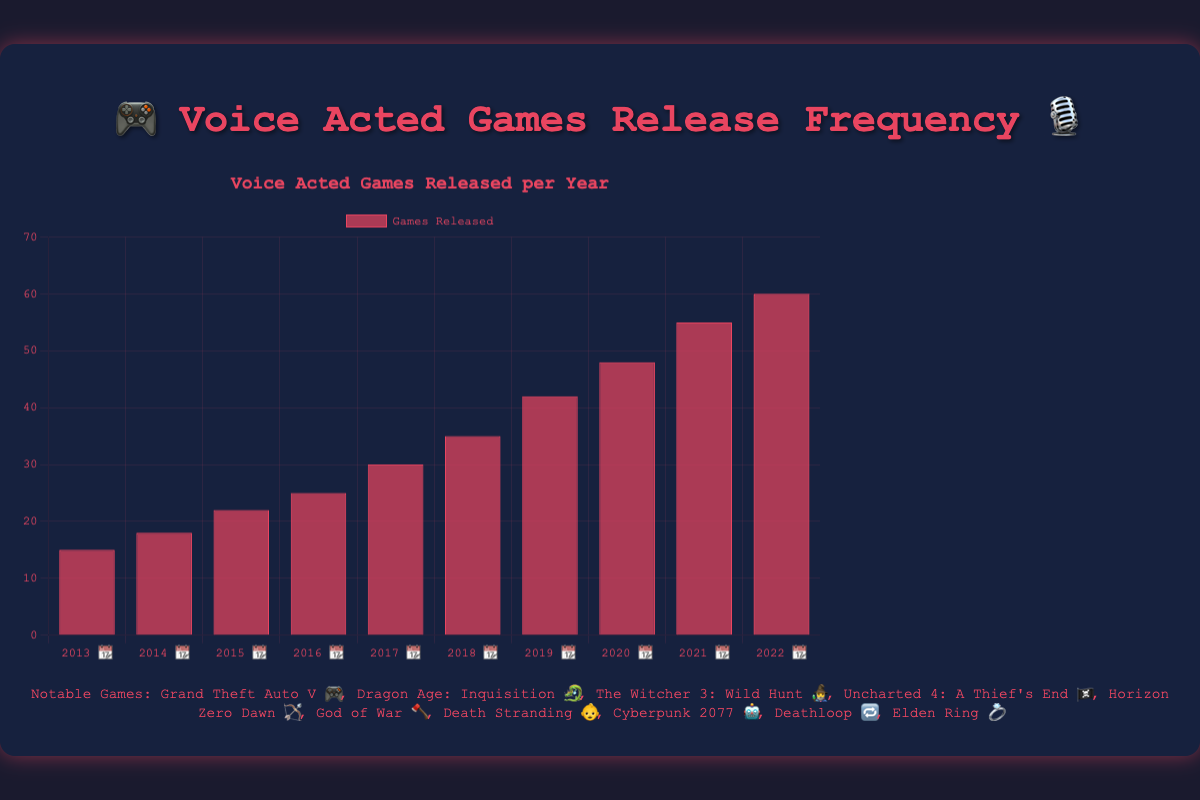How many games were released in 2018 📆? The y-axis represents the number of games released each year. Look for the bar labeled "2018 📆" on the x-axis and check its height to see how many games were released.
Answer: 35 What was the trend in the number of games released from 2013 📆 to 2022 📆? The height of the bars increases from left to right, showing a steady upward trend in the number of games released each year. This indicates that the number of games with full voice acting has been increasing every year.
Answer: Increasing Which year had the most significant increase in the number of games released compared to the previous year? Compare the differences between the heights of consecutive bars. The largest difference appears between the bars for "2019 📆" and "2020 📆".
Answer: 2020 📆 How many games were released in the years when notable games included Death Stranding 👶 and Elden Ring 💍? Death Stranding 👶 corresponds to 2019 📆, and Elden Ring 💍 corresponds to 2022 📆. Locate the bars for these years and add their respective heights.
Answer: 42 + 60 = 102 What is the average number of games released per year over the past decade? Sum the total number of games released from 2013 📆 to 2022 📆 and divide by the number of years (10). The sum is 15 + 18 + 22 + 25 + 30 + 35 + 42 + 48 + 55 + 60 = 350. Divide 350 by 10 to get the average.
Answer: 35 Which years have notable games related to fantasy or mythological themes? The notable games list includes: Dragon Age: Inquisition 🐉 (2014 📆), The Witcher 3: Wild Hunt 🧙‍♂️ (2015 📆), Horizon Zero Dawn 🏹 (2017 📆), Elden Ring 💍 (2022 📆). Identify the corresponding years.
Answer: 2014 📆, 2015 📆, 2017 📆, 2022 📆 What is the median number of games released per year over the past decade? Arrange the number of games released each year in ascending order: 15, 18, 22, 25, 30, 35, 42, 48, 55, 60. The median is the middle value or the average of the two middle values if the total count is even.
Answer: (30 + 35) / 2 = 32.5 How many more games were released in 2021 📆 compared to 2013 📆? Find the bars for 2021 📆 and 2013 📆 and subtract the number of games released in 2013 📆 from the number released in 2021 📆.
Answer: 55 - 15 = 40 Which notable game among the list appeared earliest in the decade? The notable games list includes: Grand Theft Auto V 🎮 (2013 📆). Verify its position in the list and the corresponding year to confirm it is the earliest.
Answer: Grand Theft Auto V 🎮 What is the ratio of games released in 2020 📆 to those released in 2015 📆? Find the bars for 2020 📆 and 2015 📆, and calculate the ratio by dividing the number of games released in 2020 📆 by the number released in 2015 📆.
Answer: 48 / 22 ≈ 2.18 